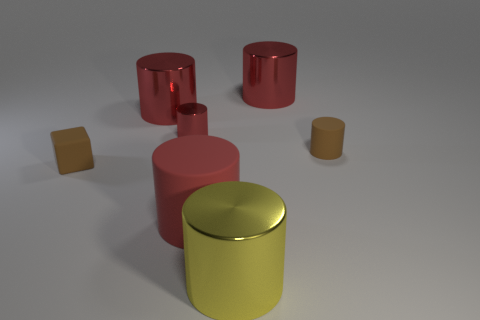Subtract all red cylinders. How many were subtracted if there are2red cylinders left? 2 Subtract all matte cylinders. How many cylinders are left? 4 Subtract 1 blocks. How many blocks are left? 0 Add 1 red things. How many objects exist? 8 Subtract all brown cylinders. How many cylinders are left? 5 Subtract all cubes. How many objects are left? 6 Subtract all blue blocks. Subtract all cyan spheres. How many blocks are left? 1 Subtract all gray blocks. How many brown cylinders are left? 1 Subtract all large matte objects. Subtract all tiny blocks. How many objects are left? 5 Add 7 yellow things. How many yellow things are left? 8 